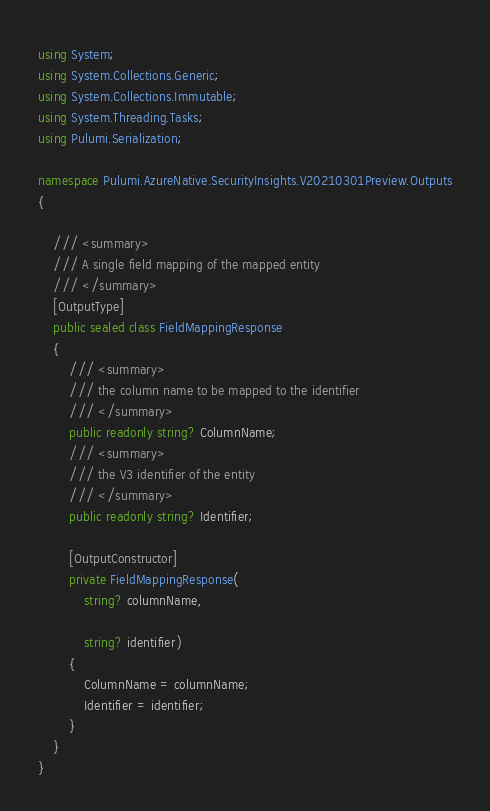Convert code to text. <code><loc_0><loc_0><loc_500><loc_500><_C#_>using System;
using System.Collections.Generic;
using System.Collections.Immutable;
using System.Threading.Tasks;
using Pulumi.Serialization;

namespace Pulumi.AzureNative.SecurityInsights.V20210301Preview.Outputs
{

    /// <summary>
    /// A single field mapping of the mapped entity
    /// </summary>
    [OutputType]
    public sealed class FieldMappingResponse
    {
        /// <summary>
        /// the column name to be mapped to the identifier
        /// </summary>
        public readonly string? ColumnName;
        /// <summary>
        /// the V3 identifier of the entity
        /// </summary>
        public readonly string? Identifier;

        [OutputConstructor]
        private FieldMappingResponse(
            string? columnName,

            string? identifier)
        {
            ColumnName = columnName;
            Identifier = identifier;
        }
    }
}
</code> 